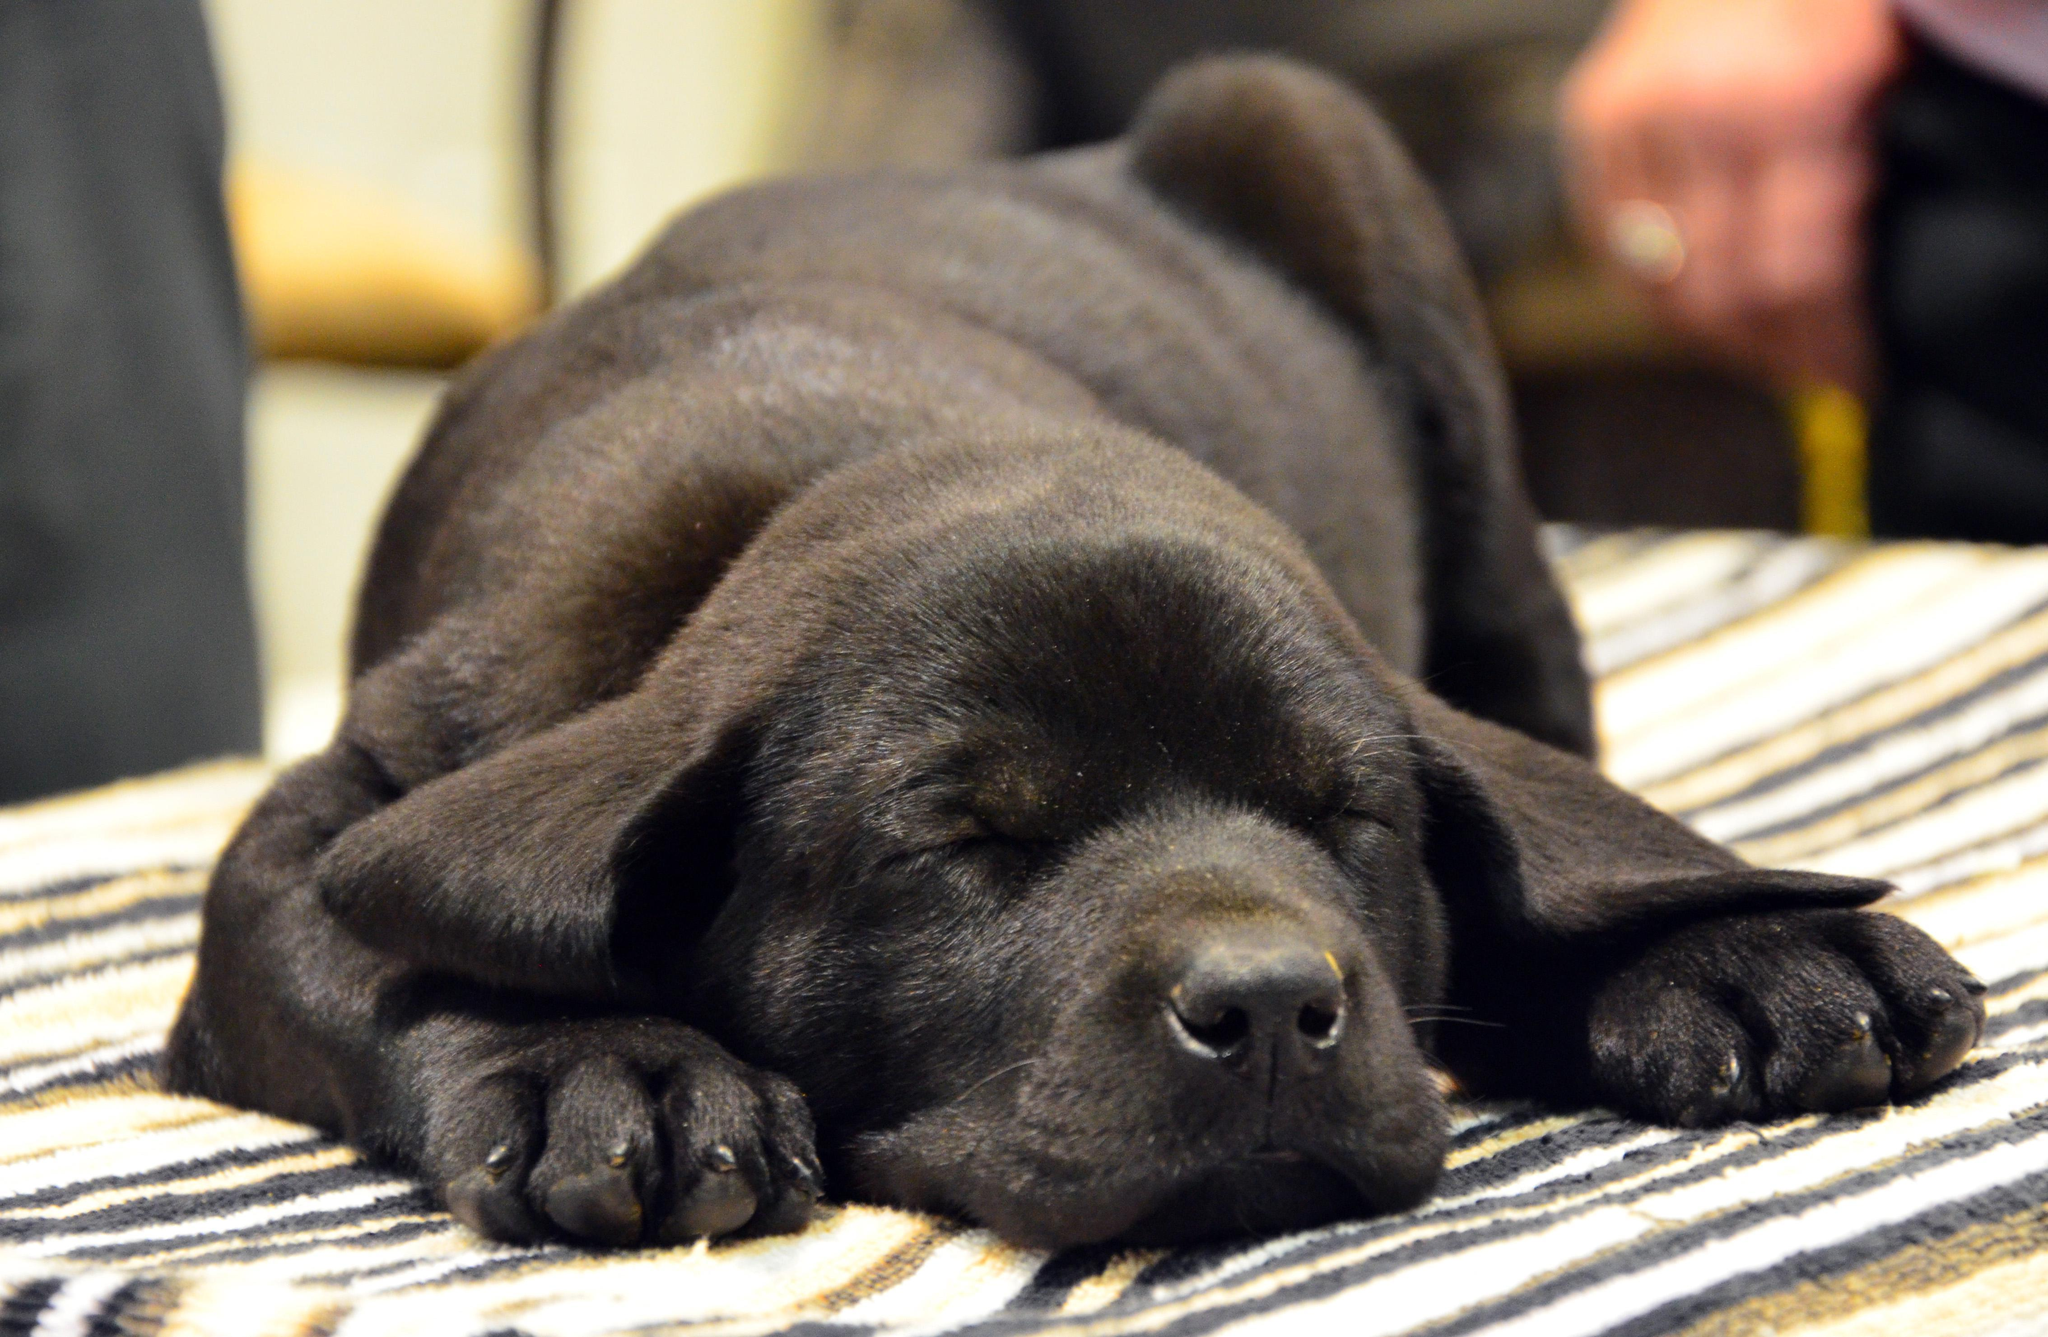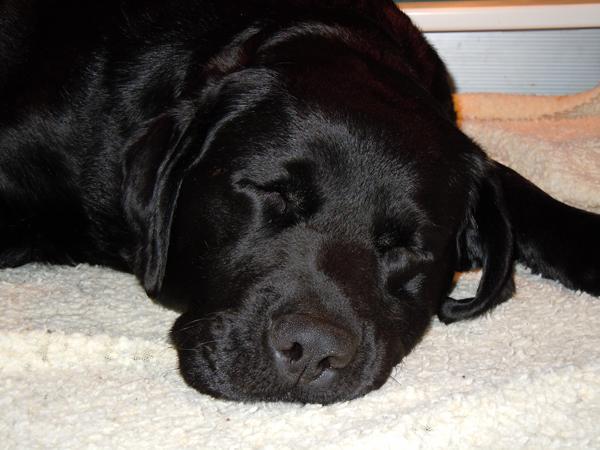The first image is the image on the left, the second image is the image on the right. Considering the images on both sides, is "A single dog is sleeping in each of the pictures." valid? Answer yes or no. Yes. The first image is the image on the left, the second image is the image on the right. For the images displayed, is the sentence "Each image shows one sleeping dog, and each dog is sleeping with its head facing the camera and rightside-up." factually correct? Answer yes or no. Yes. 